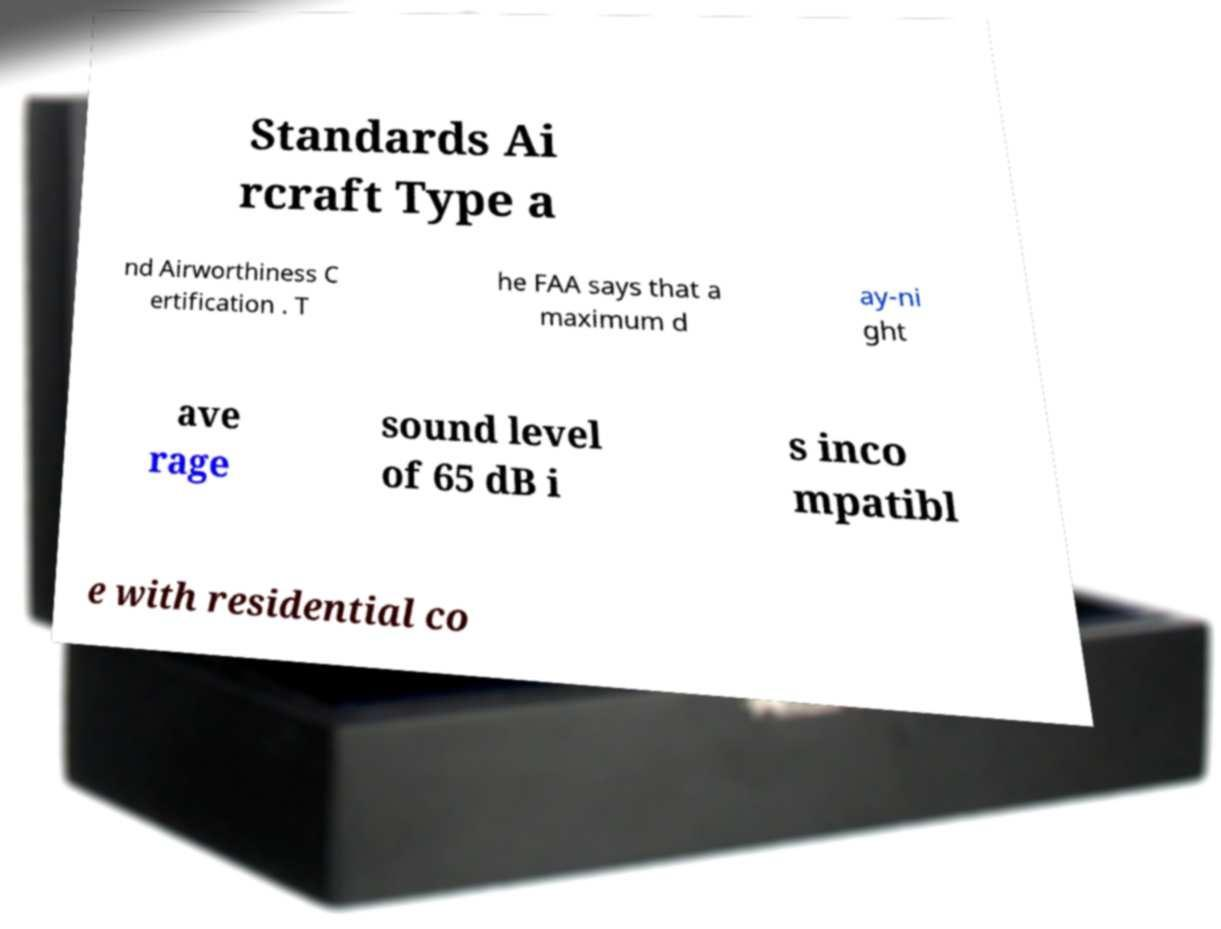I need the written content from this picture converted into text. Can you do that? Standards Ai rcraft Type a nd Airworthiness C ertification . T he FAA says that a maximum d ay-ni ght ave rage sound level of 65 dB i s inco mpatibl e with residential co 